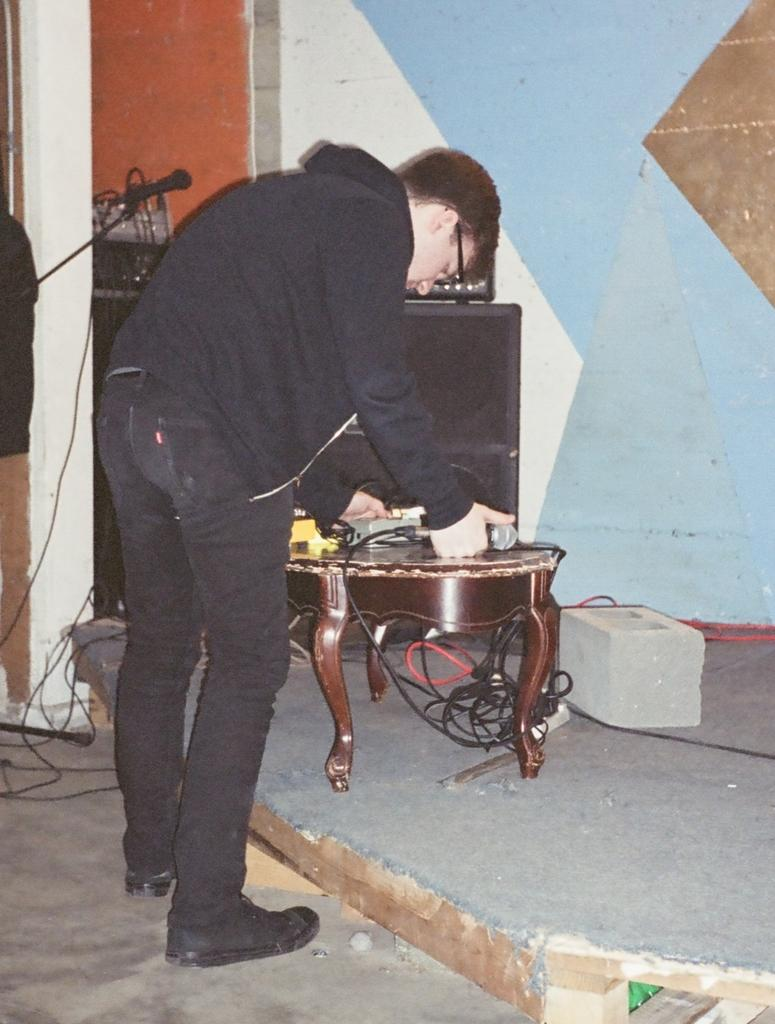What is the main subject of the image? The main subject of the image is a man. What is the man doing in the image? The man is standing and holding a mic in his hand. What object is present on a table in the image? There is a speaker on a table in the image. What type of honey is being reported on the news in the image? There is no news or honey present in the image; it features a man standing with a mic and a speaker on a table. 